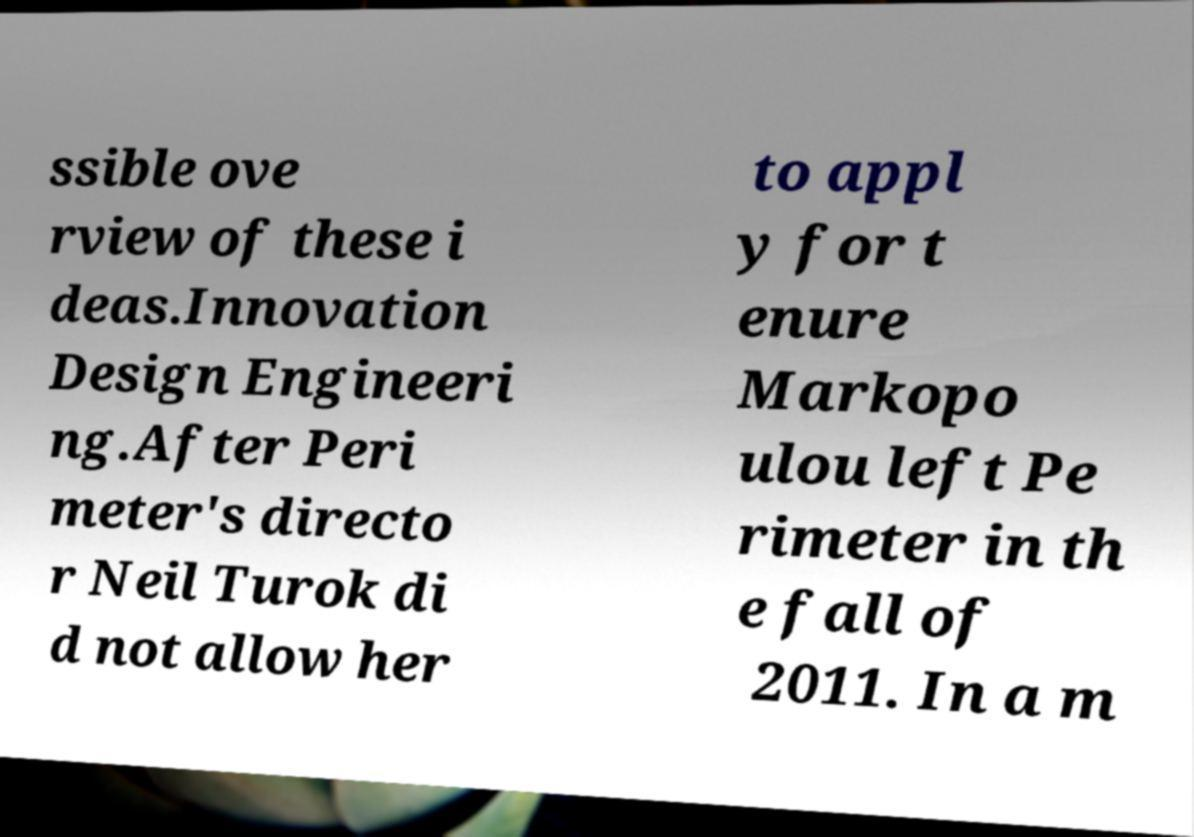Could you assist in decoding the text presented in this image and type it out clearly? ssible ove rview of these i deas.Innovation Design Engineeri ng.After Peri meter's directo r Neil Turok di d not allow her to appl y for t enure Markopo ulou left Pe rimeter in th e fall of 2011. In a m 